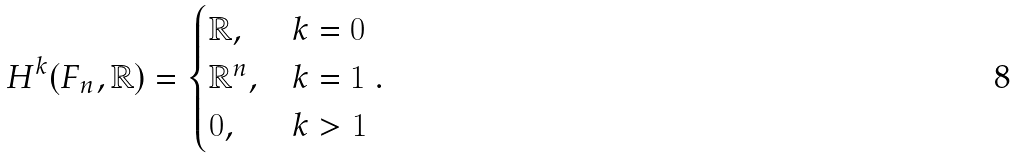<formula> <loc_0><loc_0><loc_500><loc_500>H ^ { k } ( F _ { n } , \mathbb { R } ) = \begin{cases} \mathbb { R } , & k = 0 \\ \mathbb { R } ^ { n } , & k = 1 \\ 0 , & k > 1 \\ \end{cases} .</formula> 